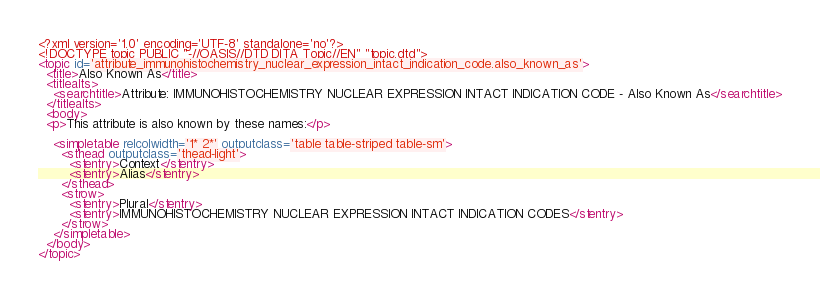<code> <loc_0><loc_0><loc_500><loc_500><_XML_><?xml version='1.0' encoding='UTF-8' standalone='no'?>
<!DOCTYPE topic PUBLIC "-//OASIS//DTD DITA Topic//EN" "topic.dtd">
<topic id='attribute_immunohistochemistry_nuclear_expression_intact_indication_code.also_known_as'>
  <title>Also Known As</title>
  <titlealts>
    <searchtitle>Attribute: IMMUNOHISTOCHEMISTRY NUCLEAR EXPRESSION INTACT INDICATION CODE - Also Known As</searchtitle>
  </titlealts>
  <body>
  <p>This attribute is also known by these names:</p>

    <simpletable relcolwidth='1* 2*' outputclass='table table-striped table-sm'>
      <sthead outputclass='thead-light'>
        <stentry>Context</stentry>
        <stentry>Alias</stentry>
      </sthead>
      <strow>
        <stentry>Plural</stentry>
        <stentry>IMMUNOHISTOCHEMISTRY NUCLEAR EXPRESSION INTACT INDICATION CODES</stentry>
      </strow>
    </simpletable>
  </body>
</topic></code> 